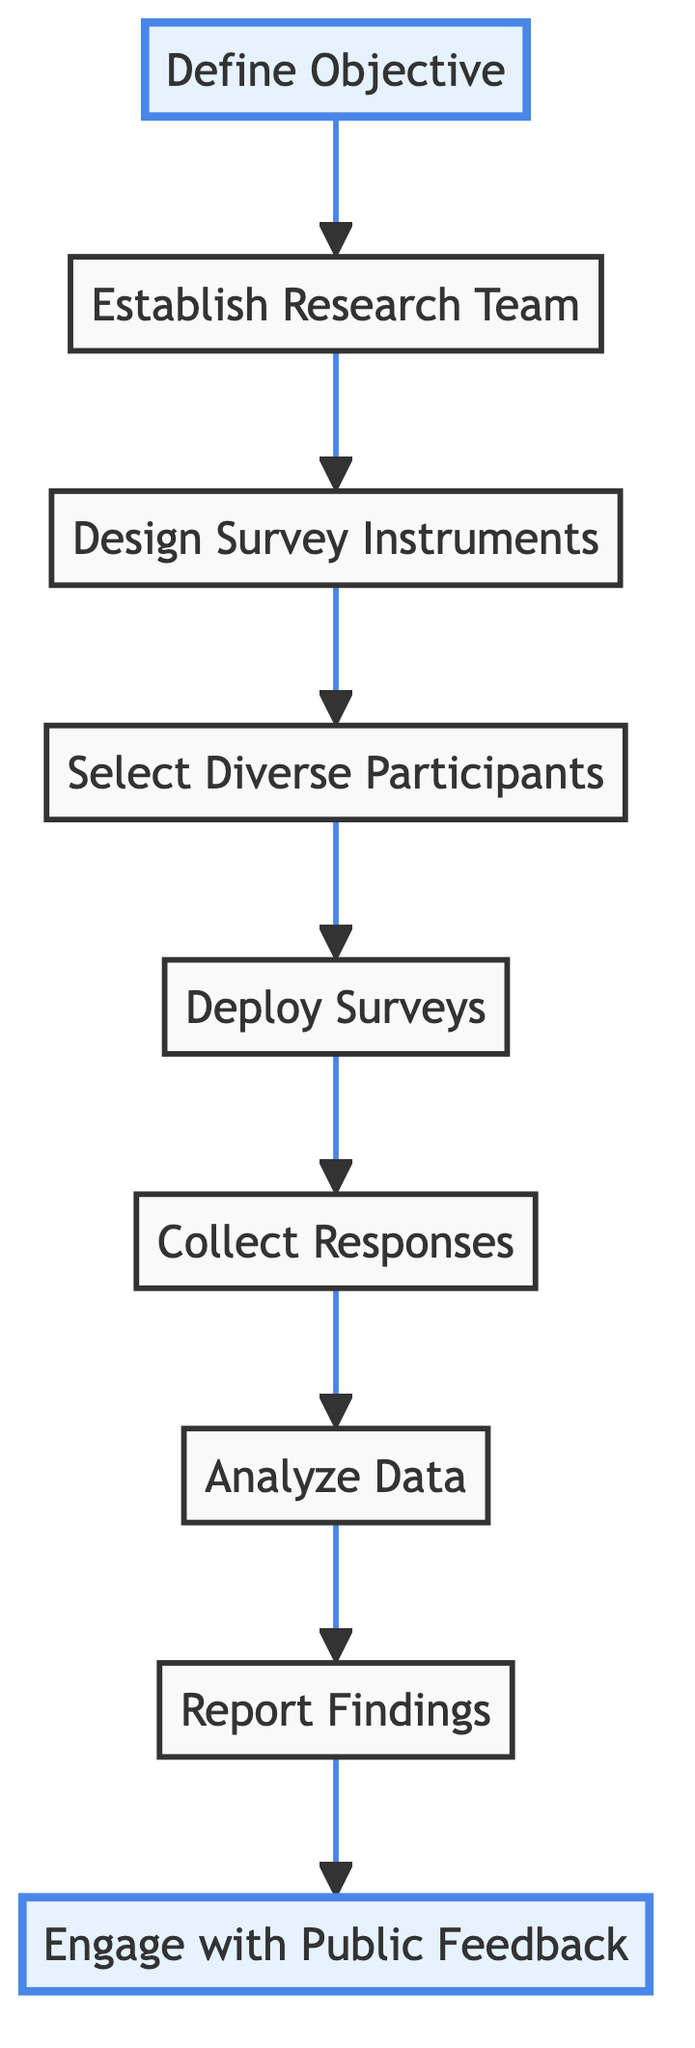What is the first step in the workflow? The diagram indicates that the first step in the workflow for sourcing public opinions on Confederate monuments is "Define Objective."
Answer: Define Objective How many total steps are there in the workflow? By counting each distinct labeled step in the diagram, there are nine total steps in the workflow.
Answer: 9 What comes after designing survey instruments? According to the flow of the diagram, the step that follows "Design Survey Instruments" is "Select Diverse Participants."
Answer: Select Diverse Participants Which organizations are suggested for input while designing the survey instruments? The diagram includes references to polling experts at organizations such as the Pew Research Center and Gallup for input when designing survey instruments.
Answer: Pew Research Center and Gallup What should be the composition of the research team? The research team should be interdisciplinary and include historians, sociologists, and data scientists as suggested in the workflow.
Answer: Historians, sociologists, and data scientists What is the last step in the workflow? The diagram shows that the last step in the workflow for sourcing public opinions on Confederate monuments is "Engage with Public Feedback."
Answer: Engage with Public Feedback How does the workflow ensure a diverse sample of participants? The workflow specifies that it uses stratified sampling to ensure a representative sample, considering geography, race, age, and political affiliation.
Answer: Stratified sampling What type of analysis is recommended after collecting responses? The workflow suggests conducting both qualitative and quantitative analysis to identify key themes and trends.
Answer: Qualitative and quantitative analysis What action is taken after reporting the findings? Once findings are reported, the next action is to "Engage with Public Feedback" through discussions and public presentations.
Answer: Engage with Public Feedback 